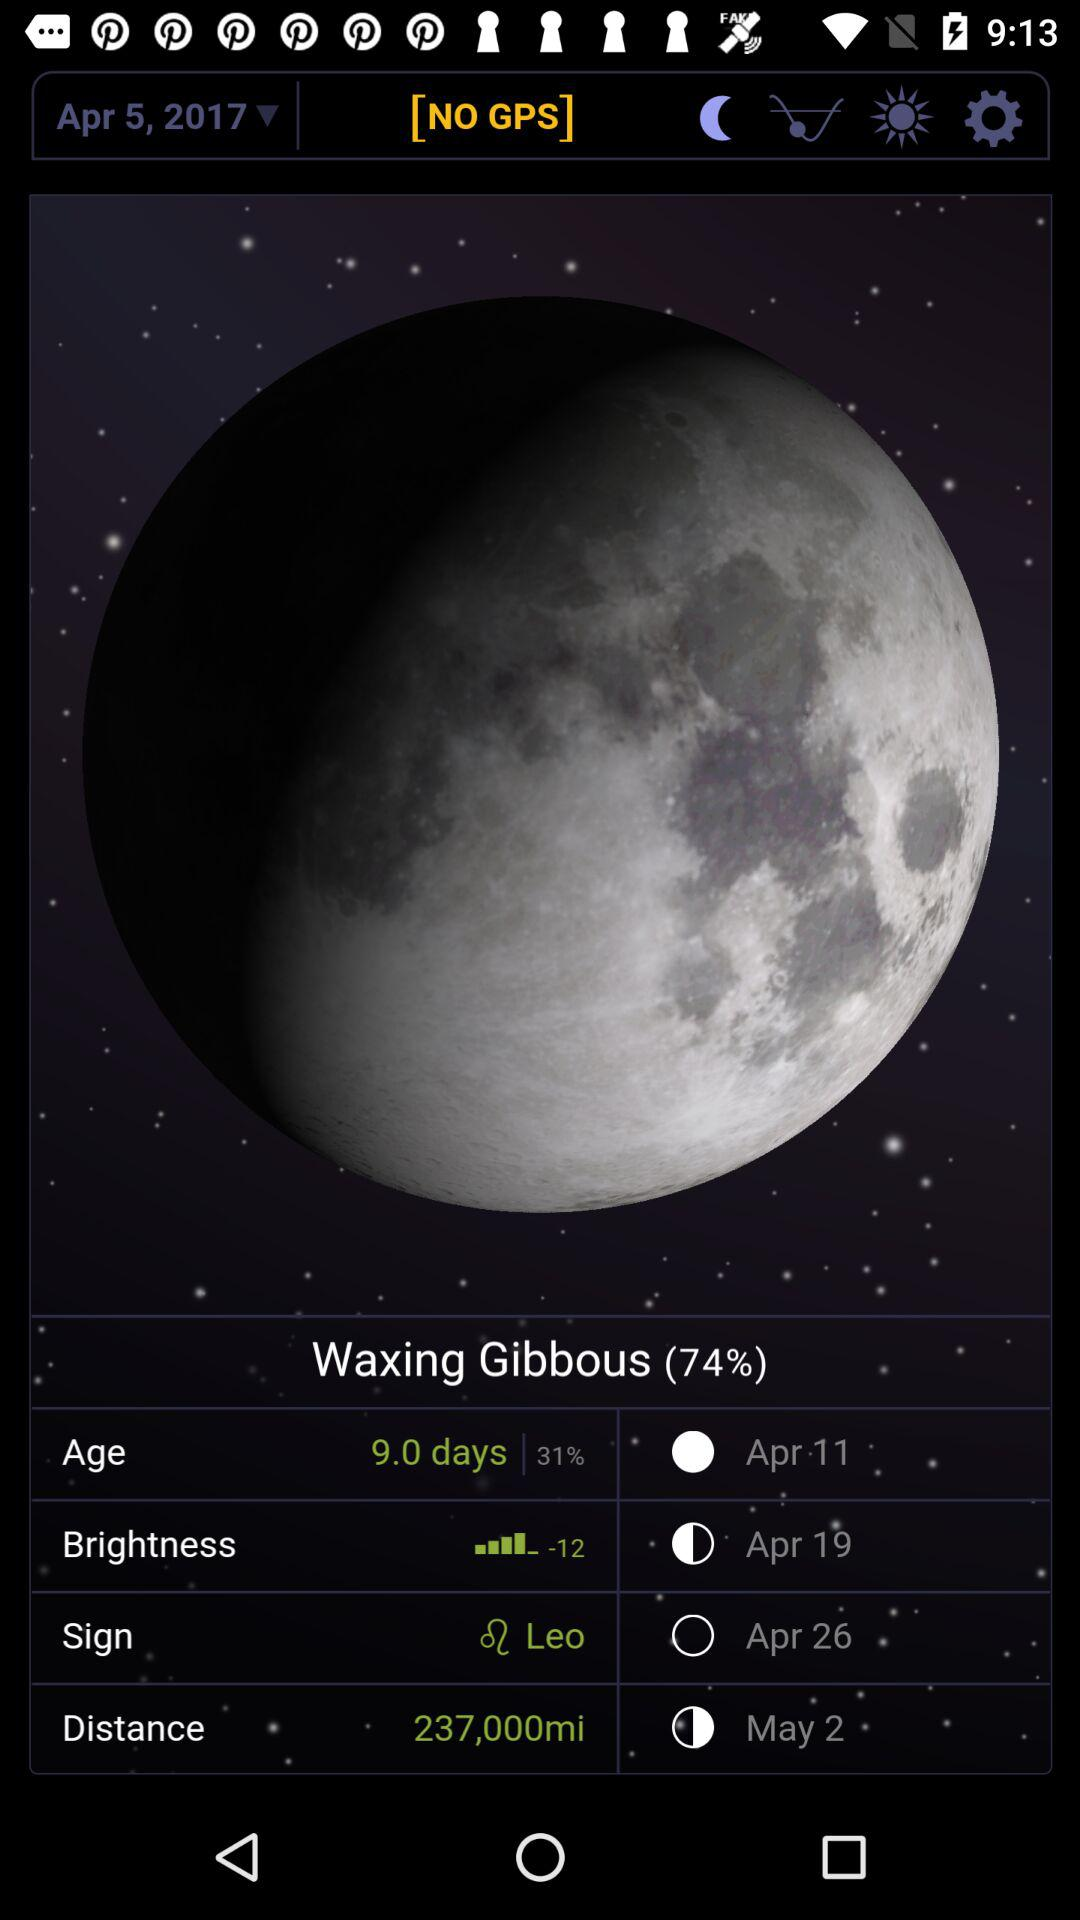What is the age percentage? The age percentage is 31. 